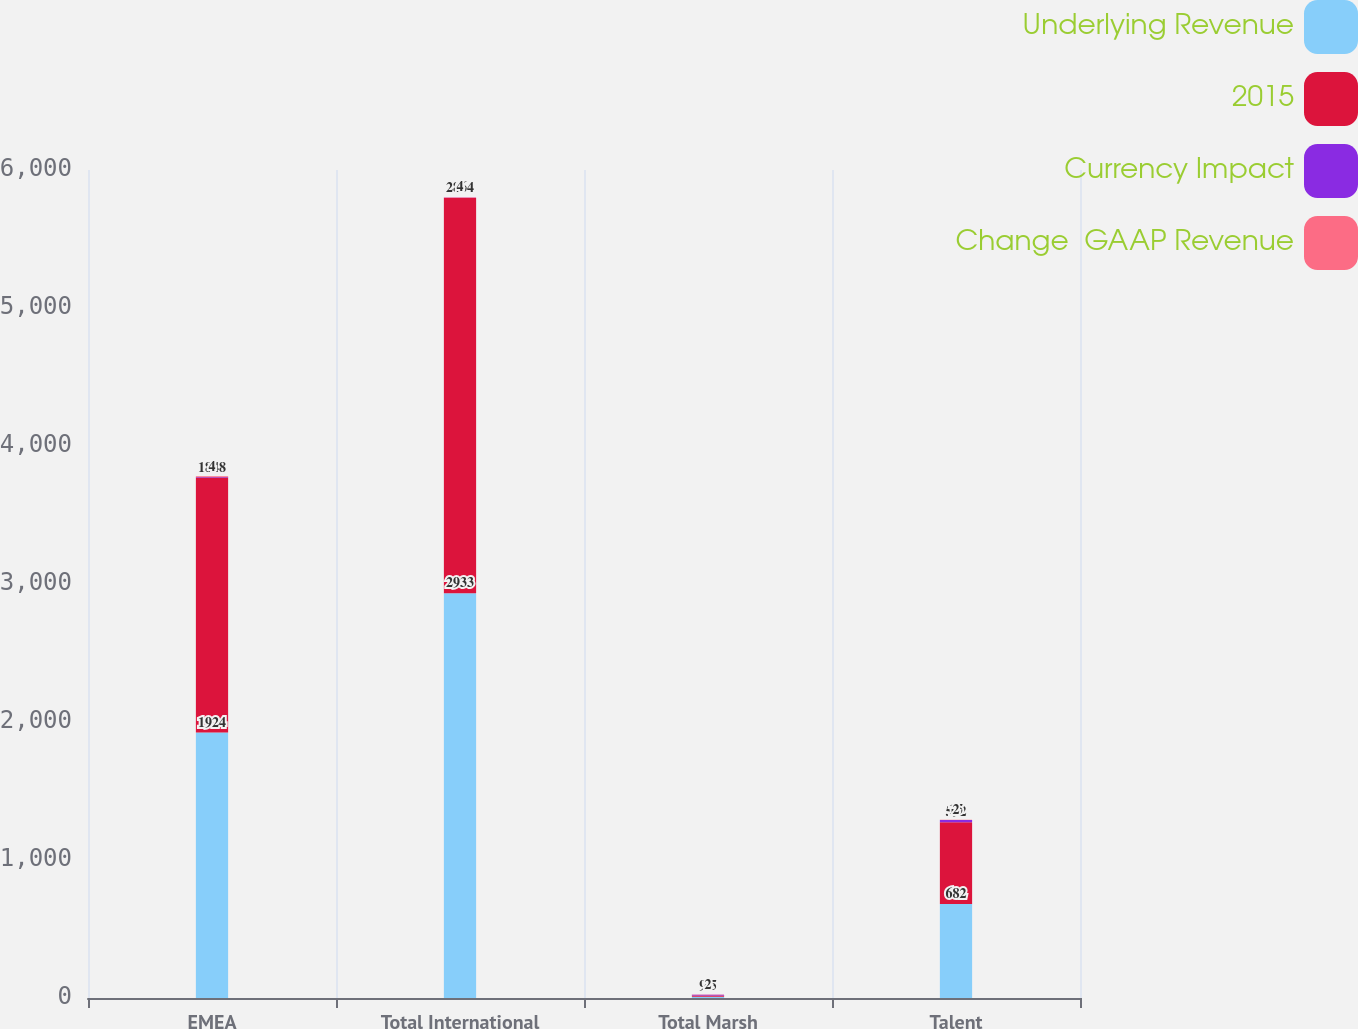Convert chart to OTSL. <chart><loc_0><loc_0><loc_500><loc_500><stacked_bar_chart><ecel><fcel>EMEA<fcel>Total International<fcel>Total Marsh<fcel>Talent<nl><fcel>Underlying Revenue<fcel>1924<fcel>2933<fcel>9.5<fcel>682<nl><fcel>2015<fcel>1848<fcel>2864<fcel>9.5<fcel>592<nl><fcel>Currency Impact<fcel>4<fcel>2<fcel>4<fcel>15<nl><fcel>Change  GAAP Revenue<fcel>4<fcel>4<fcel>2<fcel>2<nl></chart> 